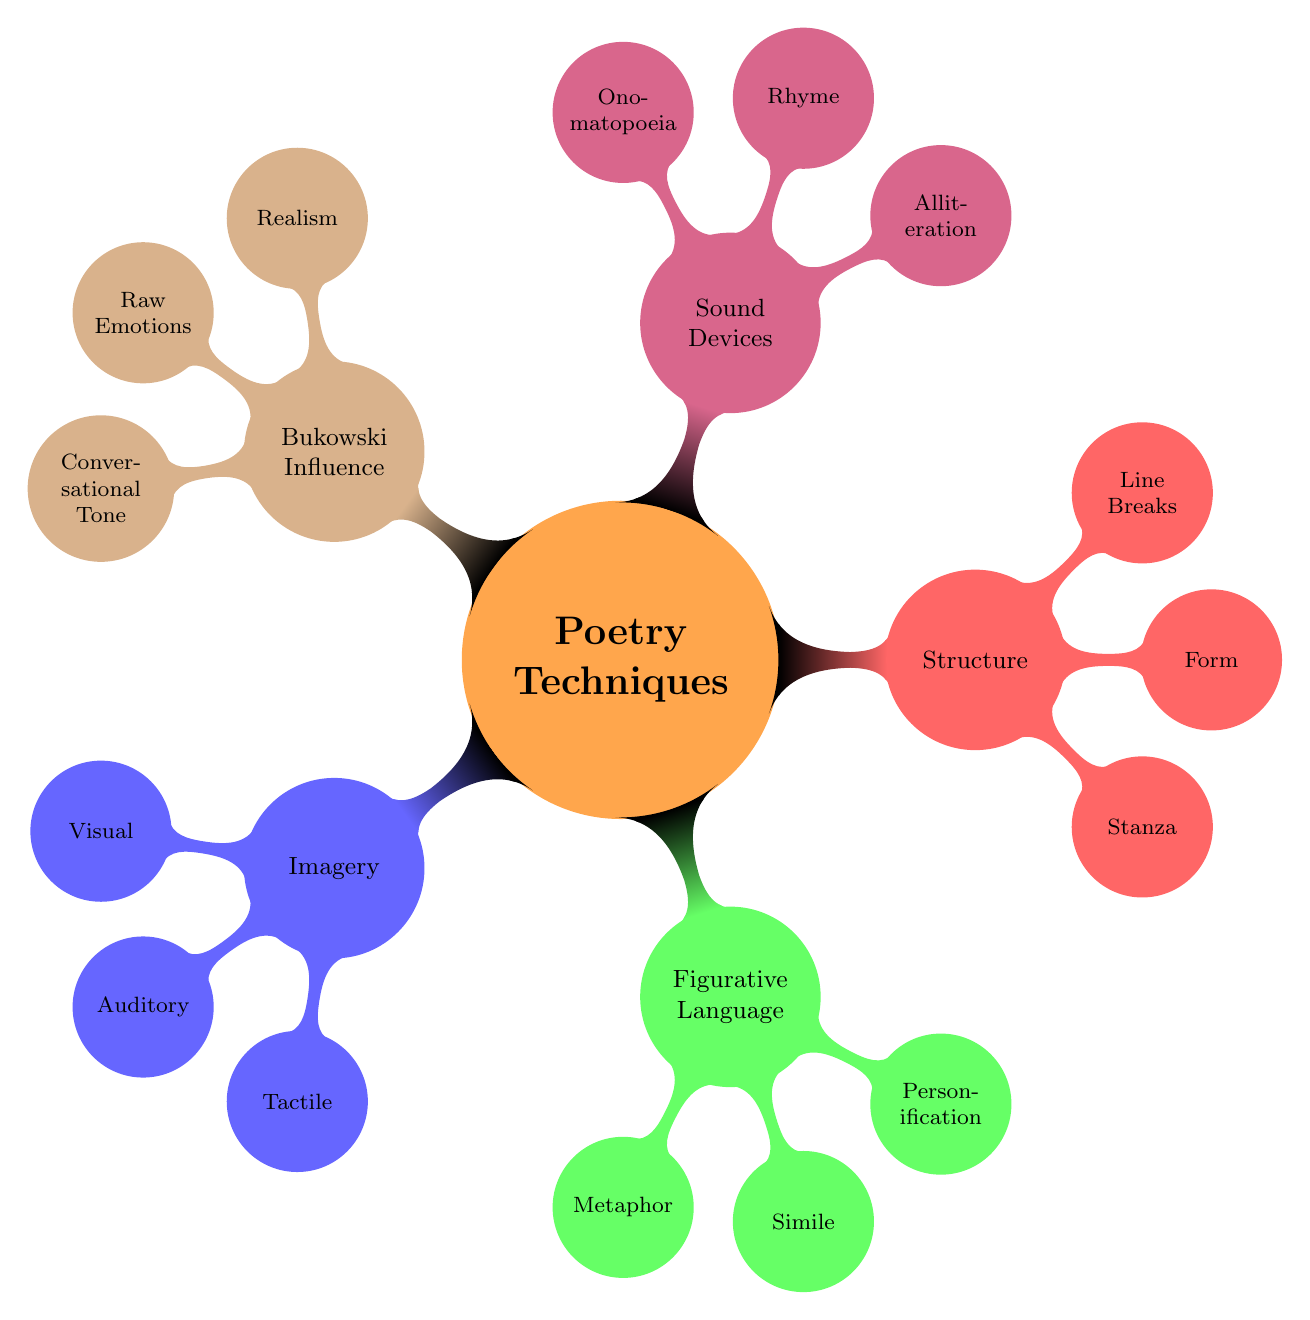What are the three types of imagery listed? The diagram shows that under the "Imagery" section, the three types are "Visual," "Auditory," and "Tactile." These can be found as direct child nodes of the "Imagery" node.
Answer: Visual, Auditory, Tactile How many sound devices are included in the diagram? The "Sound Devices" node has three child nodes: "Alliteration," "Rhyme," and "Onomatopoeia." Counting these gives a total of three sound devices.
Answer: 3 What is the color associated with Figurative Language? The "Figurative Language" node has a child color code of green!60, which is the color assigned to this section in the diagram.
Answer: Green What is the primary characteristic of Bukowski's influence on poetry? The "Bukowski Influence" node describes three main characteristics, one of which is "Raw Emotions." This term summarizes the unfiltered feelings associated with his poetry style.
Answer: Raw Emotions How does structure affect poetry according to the diagram? The "Structure" node notes three elements: "Stanza," "Form," and "Line Breaks." These elements together influence the organization and pacing of poetry, demonstrating structure's impact.
Answer: Stanza, Form, Line Breaks Which poetic technique uses comparisons with 'like' or 'as'? The child node "Simile" under "Figurative Language" is defined explicitly as comparing two unlike things using 'like' or 'as,' making it the correct answer based on the diagram's description.
Answer: Simile What does the term "Conversational Tone" refer to? In the context of "Bukowski Influence," "Conversational Tone" describes the informal and direct language reminiscent of natural speech, which is noted clearly in the diagram.
Answer: Informal and direct language What are examples of sound devices according to the map? The "Sound Devices" node includes "Alliteration," "Rhyme," and "Onomatopoeia." All these are specific examples of sound devices labeled under this section of the diagram.
Answer: Alliteration, Rhyme, Onomatopoeia 